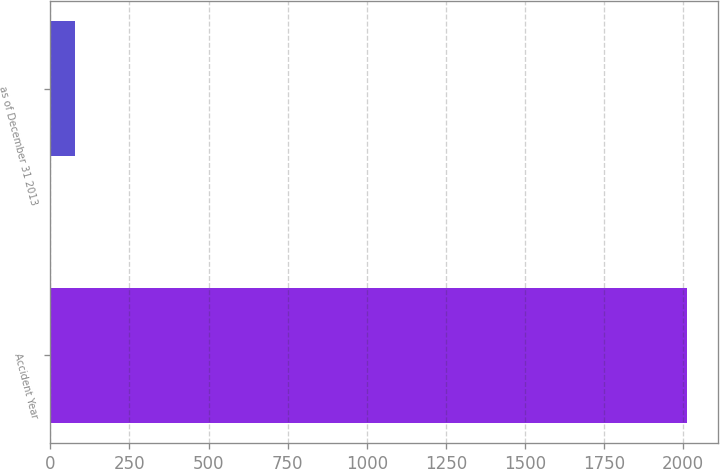Convert chart to OTSL. <chart><loc_0><loc_0><loc_500><loc_500><bar_chart><fcel>Accident Year<fcel>as of December 31 2013<nl><fcel>2011<fcel>76.7<nl></chart> 